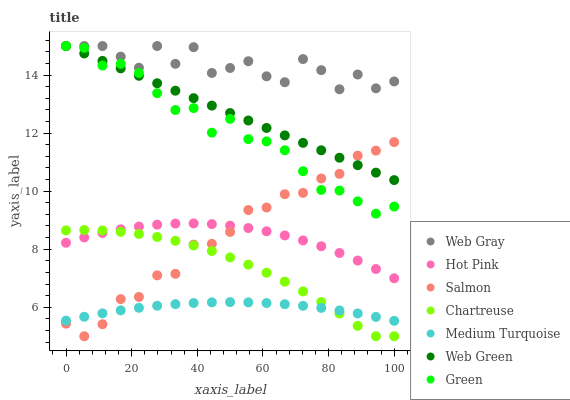Does Medium Turquoise have the minimum area under the curve?
Answer yes or no. Yes. Does Web Gray have the maximum area under the curve?
Answer yes or no. Yes. Does Hot Pink have the minimum area under the curve?
Answer yes or no. No. Does Hot Pink have the maximum area under the curve?
Answer yes or no. No. Is Web Green the smoothest?
Answer yes or no. Yes. Is Web Gray the roughest?
Answer yes or no. Yes. Is Hot Pink the smoothest?
Answer yes or no. No. Is Hot Pink the roughest?
Answer yes or no. No. Does Salmon have the lowest value?
Answer yes or no. Yes. Does Hot Pink have the lowest value?
Answer yes or no. No. Does Green have the highest value?
Answer yes or no. Yes. Does Hot Pink have the highest value?
Answer yes or no. No. Is Medium Turquoise less than Web Green?
Answer yes or no. Yes. Is Hot Pink greater than Medium Turquoise?
Answer yes or no. Yes. Does Web Green intersect Web Gray?
Answer yes or no. Yes. Is Web Green less than Web Gray?
Answer yes or no. No. Is Web Green greater than Web Gray?
Answer yes or no. No. Does Medium Turquoise intersect Web Green?
Answer yes or no. No. 